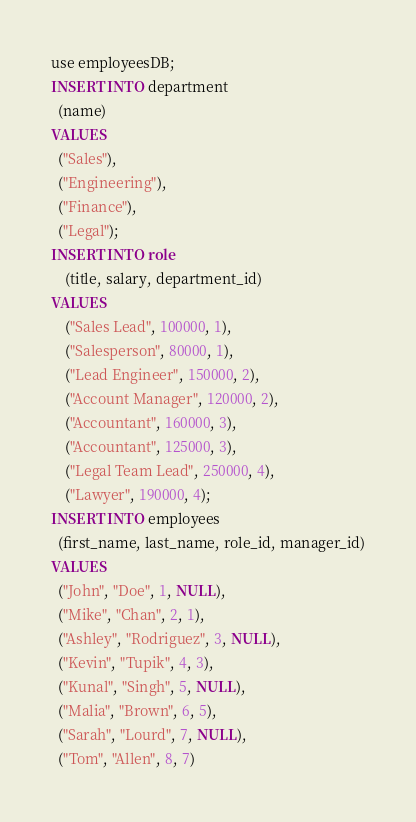Convert code to text. <code><loc_0><loc_0><loc_500><loc_500><_SQL_>use employeesDB;
INSERT INTO department
  (name)
VALUES
  ("Sales"),
  ("Engineering"),
  ("Finance"),
  ("Legal");
INSERT INTO role
    (title, salary, department_id)
VALUES
    ("Sales Lead", 100000, 1),
    ("Salesperson", 80000, 1),
    ("Lead Engineer", 150000, 2),
    ("Account Manager", 120000, 2),
    ("Accountant", 160000, 3),
    ("Accountant", 125000, 3),
    ("Legal Team Lead", 250000, 4),
    ("Lawyer", 190000, 4);
INSERT INTO employees
  (first_name, last_name, role_id, manager_id)
VALUES
  ("John", "Doe", 1, NULL),
  ("Mike", "Chan", 2, 1),
  ("Ashley", "Rodriguez", 3, NULL),
  ("Kevin", "Tupik", 4, 3),
  ("Kunal", "Singh", 5, NULL),
  ("Malia", "Brown", 6, 5),
  ("Sarah", "Lourd", 7, NULL),
  ("Tom", "Allen", 8, 7)</code> 